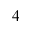Convert formula to latex. <formula><loc_0><loc_0><loc_500><loc_500>_ { 4 }</formula> 